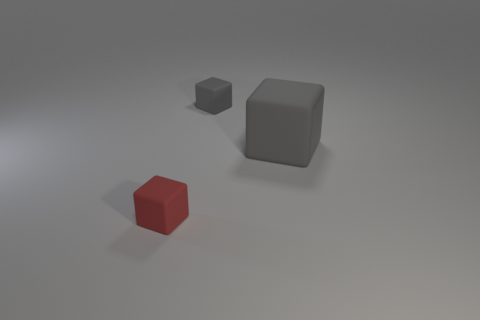Subtract all large gray cubes. How many cubes are left? 2 Add 3 gray matte things. How many objects exist? 6 Subtract 1 blocks. How many blocks are left? 2 Subtract all red cubes. How many cubes are left? 2 Subtract all tiny matte blocks. Subtract all tiny cyan metallic objects. How many objects are left? 1 Add 3 tiny matte cubes. How many tiny matte cubes are left? 5 Add 1 gray cubes. How many gray cubes exist? 3 Subtract 0 brown cylinders. How many objects are left? 3 Subtract all red blocks. Subtract all blue balls. How many blocks are left? 2 Subtract all green spheres. How many purple cubes are left? 0 